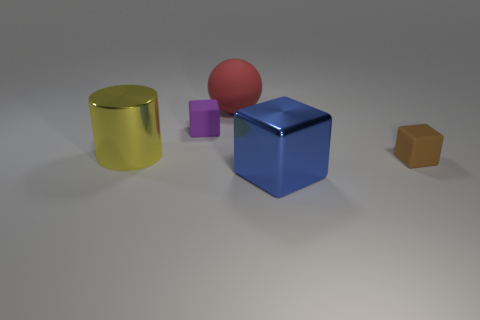Add 3 matte balls. How many objects exist? 8 Subtract all blocks. How many objects are left? 2 Add 2 matte blocks. How many matte blocks exist? 4 Subtract 1 blue blocks. How many objects are left? 4 Subtract all small things. Subtract all tiny brown cubes. How many objects are left? 2 Add 4 rubber things. How many rubber things are left? 7 